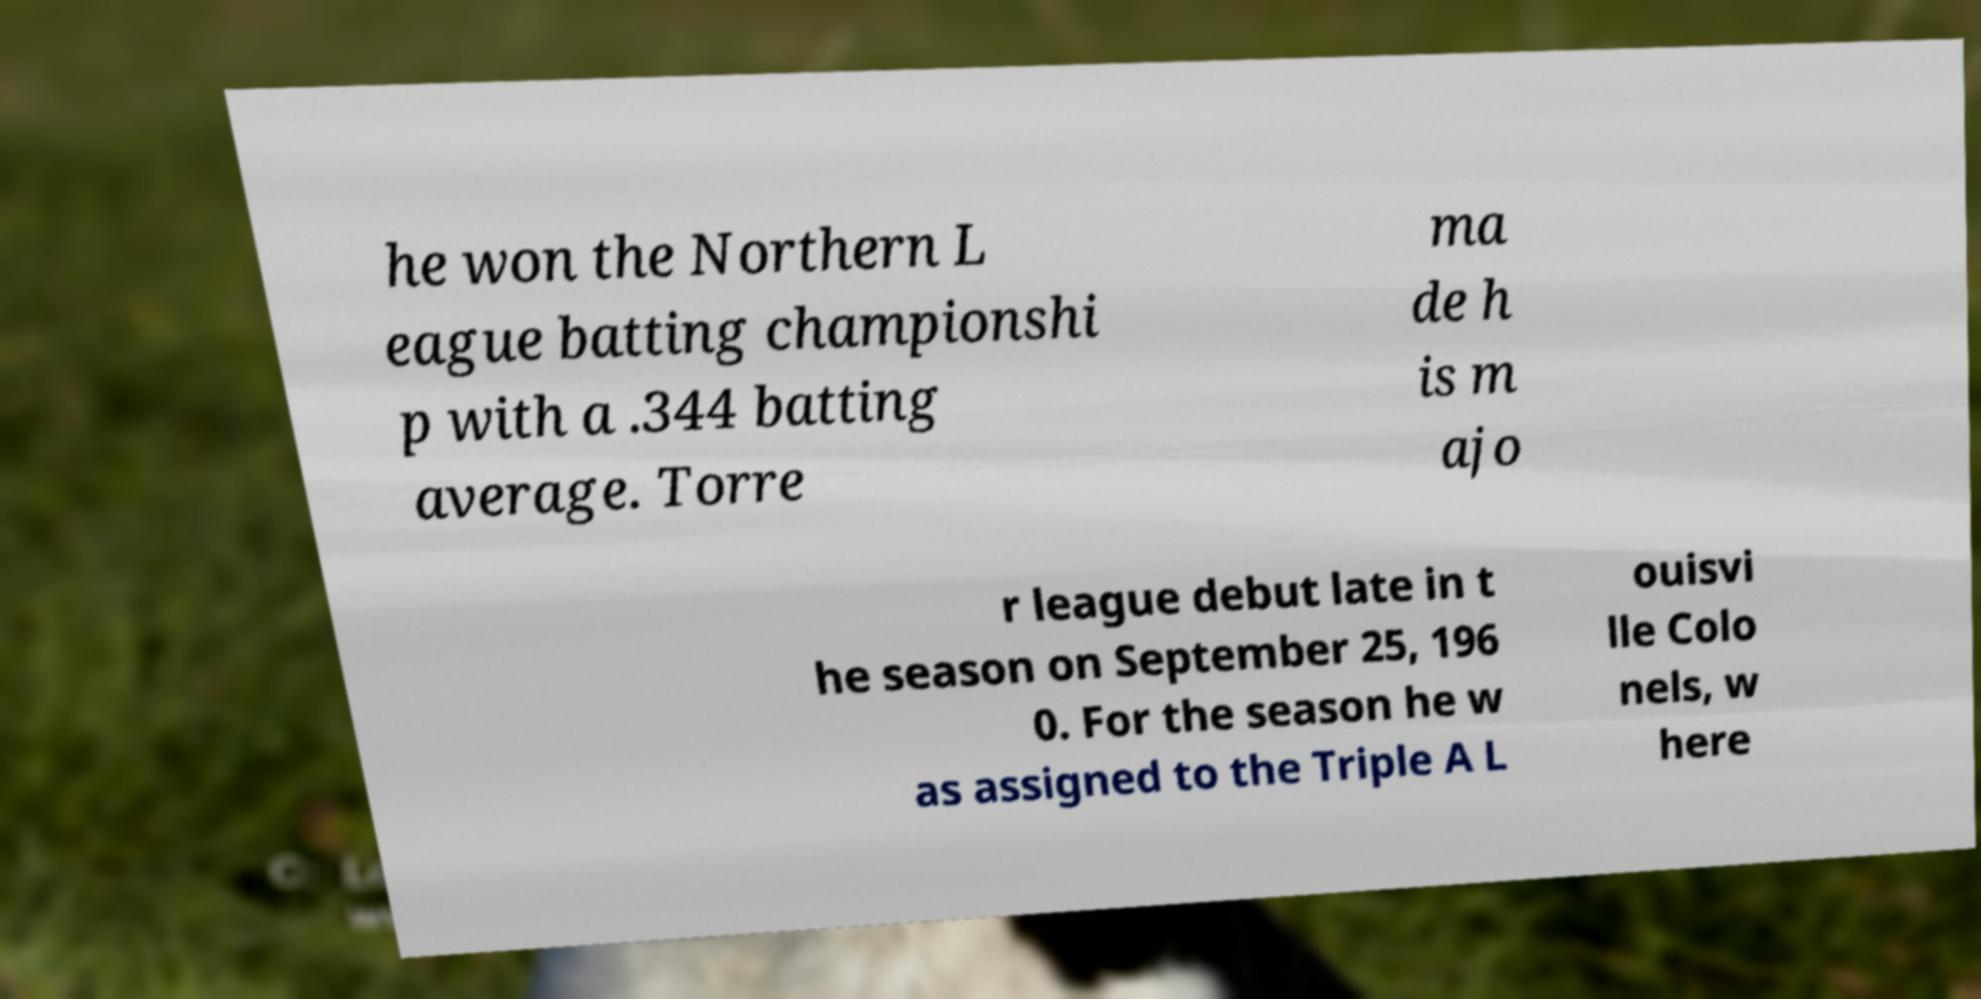Please read and relay the text visible in this image. What does it say? he won the Northern L eague batting championshi p with a .344 batting average. Torre ma de h is m ajo r league debut late in t he season on September 25, 196 0. For the season he w as assigned to the Triple A L ouisvi lle Colo nels, w here 